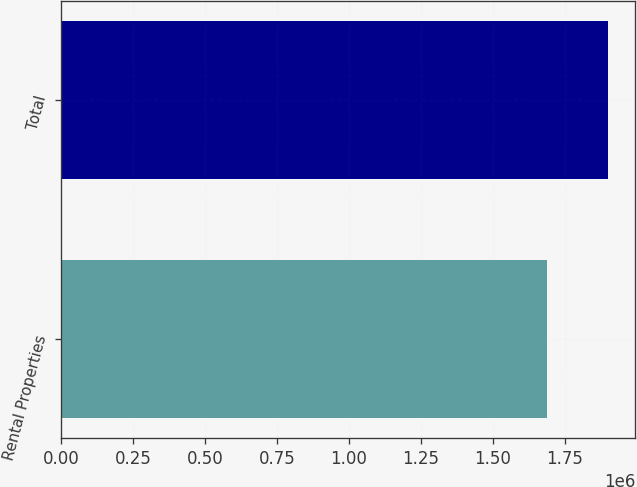Convert chart. <chart><loc_0><loc_0><loc_500><loc_500><bar_chart><fcel>Rental Properties<fcel>Total<nl><fcel>1.68644e+06<fcel>1.89928e+06<nl></chart> 